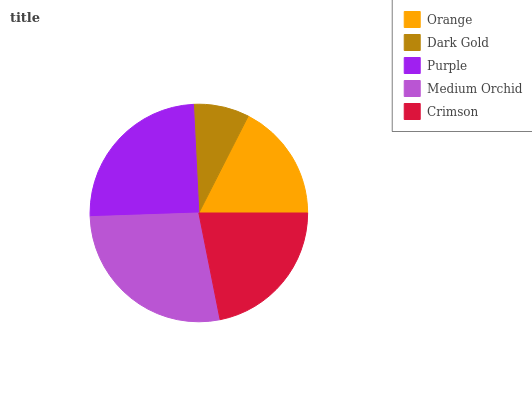Is Dark Gold the minimum?
Answer yes or no. Yes. Is Medium Orchid the maximum?
Answer yes or no. Yes. Is Purple the minimum?
Answer yes or no. No. Is Purple the maximum?
Answer yes or no. No. Is Purple greater than Dark Gold?
Answer yes or no. Yes. Is Dark Gold less than Purple?
Answer yes or no. Yes. Is Dark Gold greater than Purple?
Answer yes or no. No. Is Purple less than Dark Gold?
Answer yes or no. No. Is Crimson the high median?
Answer yes or no. Yes. Is Crimson the low median?
Answer yes or no. Yes. Is Purple the high median?
Answer yes or no. No. Is Purple the low median?
Answer yes or no. No. 